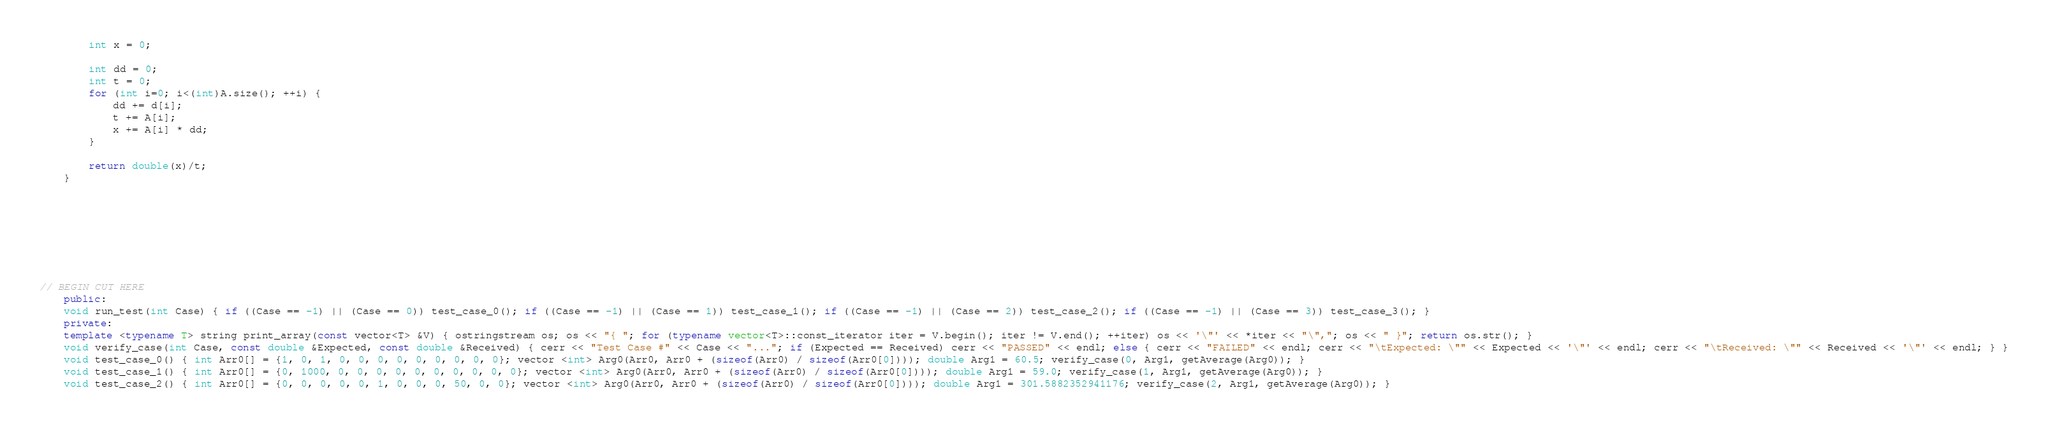Convert code to text. <code><loc_0><loc_0><loc_500><loc_500><_C++_>	    int x = 0;

        int dd = 0;
        int t = 0;
        for (int i=0; i<(int)A.size(); ++i) {
            dd += d[i];
            t += A[i];
            x += A[i] * dd;
        }

        return double(x)/t;
	}







   
// BEGIN CUT HERE
	public:
	void run_test(int Case) { if ((Case == -1) || (Case == 0)) test_case_0(); if ((Case == -1) || (Case == 1)) test_case_1(); if ((Case == -1) || (Case == 2)) test_case_2(); if ((Case == -1) || (Case == 3)) test_case_3(); }
	private:
	template <typename T> string print_array(const vector<T> &V) { ostringstream os; os << "{ "; for (typename vector<T>::const_iterator iter = V.begin(); iter != V.end(); ++iter) os << '\"' << *iter << "\","; os << " }"; return os.str(); }
	void verify_case(int Case, const double &Expected, const double &Received) { cerr << "Test Case #" << Case << "..."; if (Expected == Received) cerr << "PASSED" << endl; else { cerr << "FAILED" << endl; cerr << "\tExpected: \"" << Expected << '\"' << endl; cerr << "\tReceived: \"" << Received << '\"' << endl; } }
	void test_case_0() { int Arr0[] = {1, 0, 1, 0, 0, 0, 0, 0, 0, 0, 0, 0}; vector <int> Arg0(Arr0, Arr0 + (sizeof(Arr0) / sizeof(Arr0[0]))); double Arg1 = 60.5; verify_case(0, Arg1, getAverage(Arg0)); }
	void test_case_1() { int Arr0[] = {0, 1000, 0, 0, 0, 0, 0, 0, 0, 0, 0, 0}; vector <int> Arg0(Arr0, Arr0 + (sizeof(Arr0) / sizeof(Arr0[0]))); double Arg1 = 59.0; verify_case(1, Arg1, getAverage(Arg0)); }
	void test_case_2() { int Arr0[] = {0, 0, 0, 0, 0, 1, 0, 0, 0, 50, 0, 0}; vector <int> Arg0(Arr0, Arr0 + (sizeof(Arr0) / sizeof(Arr0[0]))); double Arg1 = 301.5882352941176; verify_case(2, Arg1, getAverage(Arg0)); }</code> 